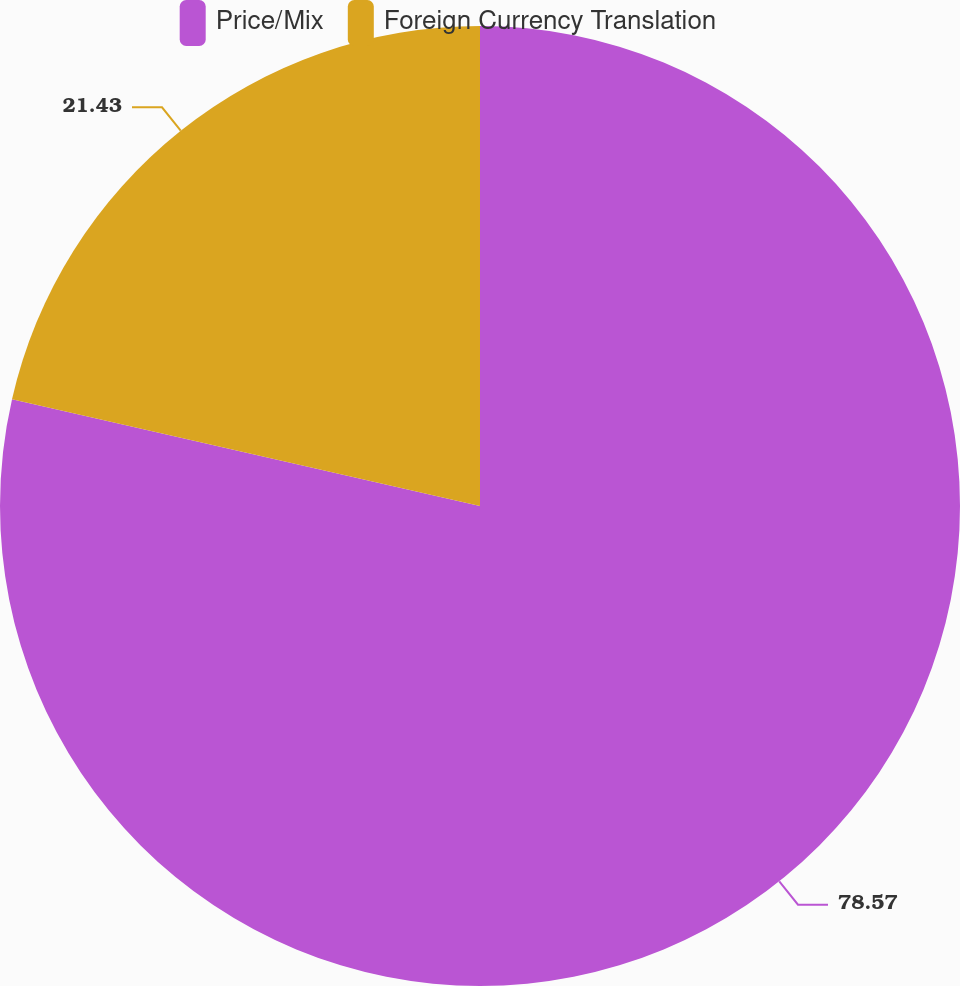<chart> <loc_0><loc_0><loc_500><loc_500><pie_chart><fcel>Price/Mix<fcel>Foreign Currency Translation<nl><fcel>78.57%<fcel>21.43%<nl></chart> 